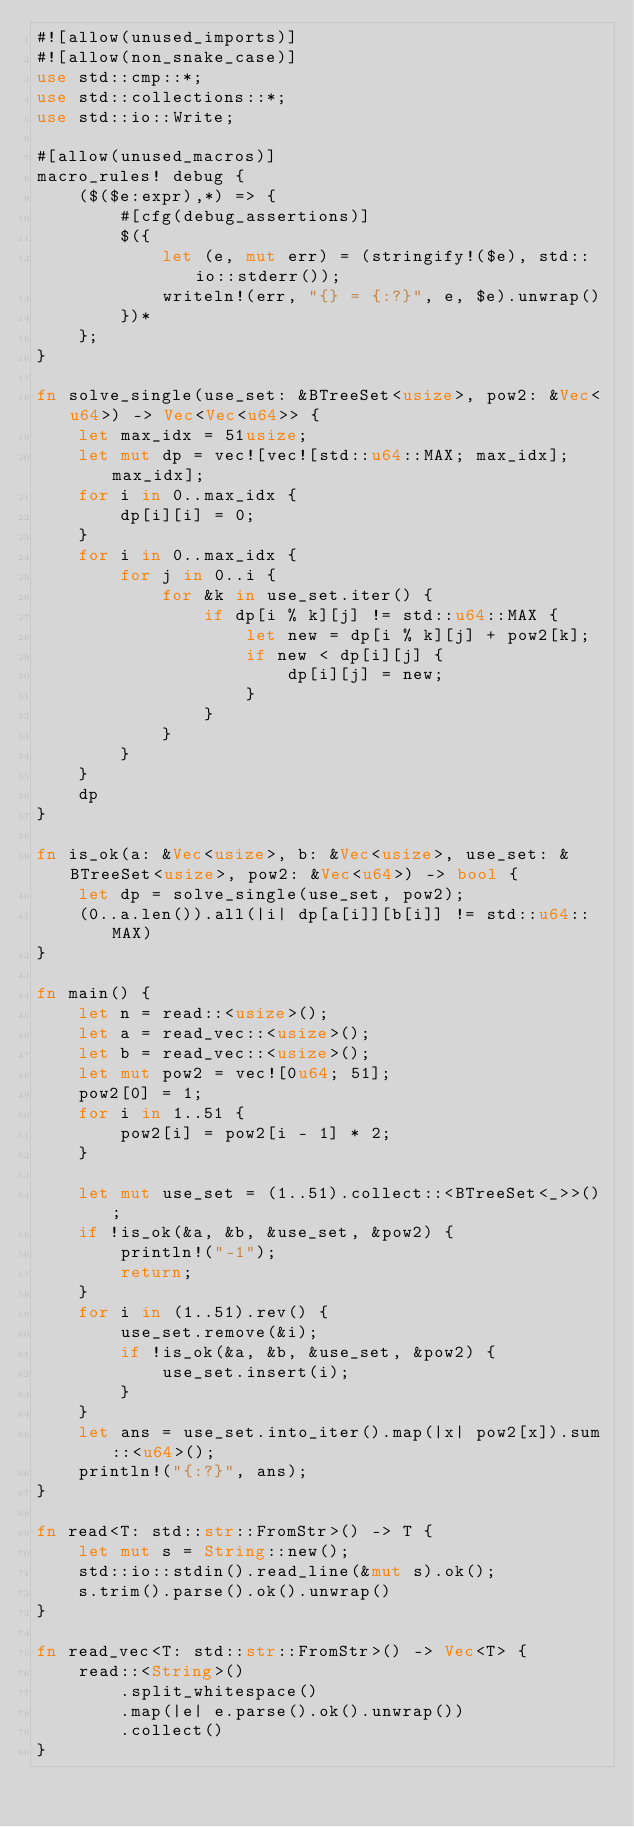Convert code to text. <code><loc_0><loc_0><loc_500><loc_500><_Rust_>#![allow(unused_imports)]
#![allow(non_snake_case)]
use std::cmp::*;
use std::collections::*;
use std::io::Write;

#[allow(unused_macros)]
macro_rules! debug {
    ($($e:expr),*) => {
        #[cfg(debug_assertions)]
        $({
            let (e, mut err) = (stringify!($e), std::io::stderr());
            writeln!(err, "{} = {:?}", e, $e).unwrap()
        })*
    };
}

fn solve_single(use_set: &BTreeSet<usize>, pow2: &Vec<u64>) -> Vec<Vec<u64>> {
    let max_idx = 51usize;
    let mut dp = vec![vec![std::u64::MAX; max_idx]; max_idx];
    for i in 0..max_idx {
        dp[i][i] = 0;
    }
    for i in 0..max_idx {
        for j in 0..i {
            for &k in use_set.iter() {
                if dp[i % k][j] != std::u64::MAX {
                    let new = dp[i % k][j] + pow2[k];
                    if new < dp[i][j] {
                        dp[i][j] = new;
                    }
                }
            }
        }
    }
    dp
}

fn is_ok(a: &Vec<usize>, b: &Vec<usize>, use_set: &BTreeSet<usize>, pow2: &Vec<u64>) -> bool {
    let dp = solve_single(use_set, pow2);
    (0..a.len()).all(|i| dp[a[i]][b[i]] != std::u64::MAX)
}

fn main() {
    let n = read::<usize>();
    let a = read_vec::<usize>();
    let b = read_vec::<usize>();
    let mut pow2 = vec![0u64; 51];
    pow2[0] = 1;
    for i in 1..51 {
        pow2[i] = pow2[i - 1] * 2;
    }

    let mut use_set = (1..51).collect::<BTreeSet<_>>();
    if !is_ok(&a, &b, &use_set, &pow2) {
        println!("-1");
        return;
    }
    for i in (1..51).rev() {
        use_set.remove(&i);
        if !is_ok(&a, &b, &use_set, &pow2) {
            use_set.insert(i);
        }
    }
    let ans = use_set.into_iter().map(|x| pow2[x]).sum::<u64>();
    println!("{:?}", ans);
}

fn read<T: std::str::FromStr>() -> T {
    let mut s = String::new();
    std::io::stdin().read_line(&mut s).ok();
    s.trim().parse().ok().unwrap()
}

fn read_vec<T: std::str::FromStr>() -> Vec<T> {
    read::<String>()
        .split_whitespace()
        .map(|e| e.parse().ok().unwrap())
        .collect()
}
</code> 